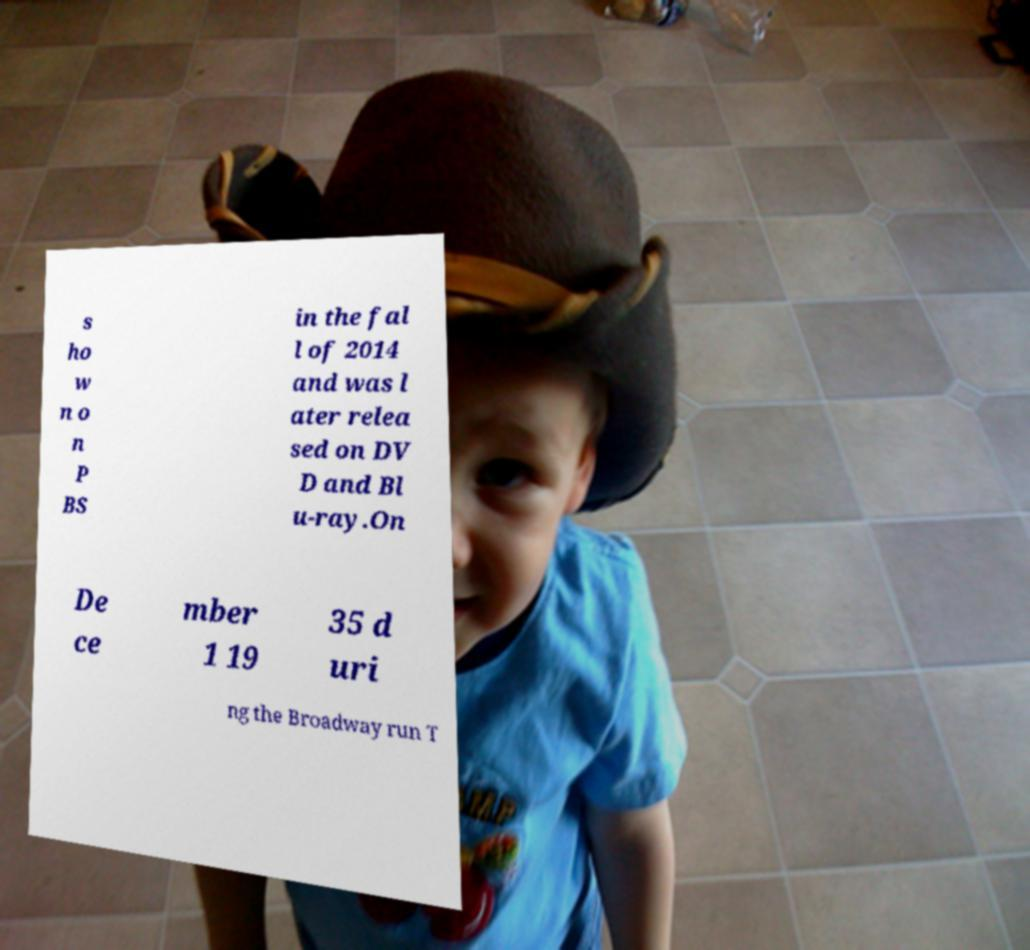I need the written content from this picture converted into text. Can you do that? s ho w n o n P BS in the fal l of 2014 and was l ater relea sed on DV D and Bl u-ray.On De ce mber 1 19 35 d uri ng the Broadway run T 